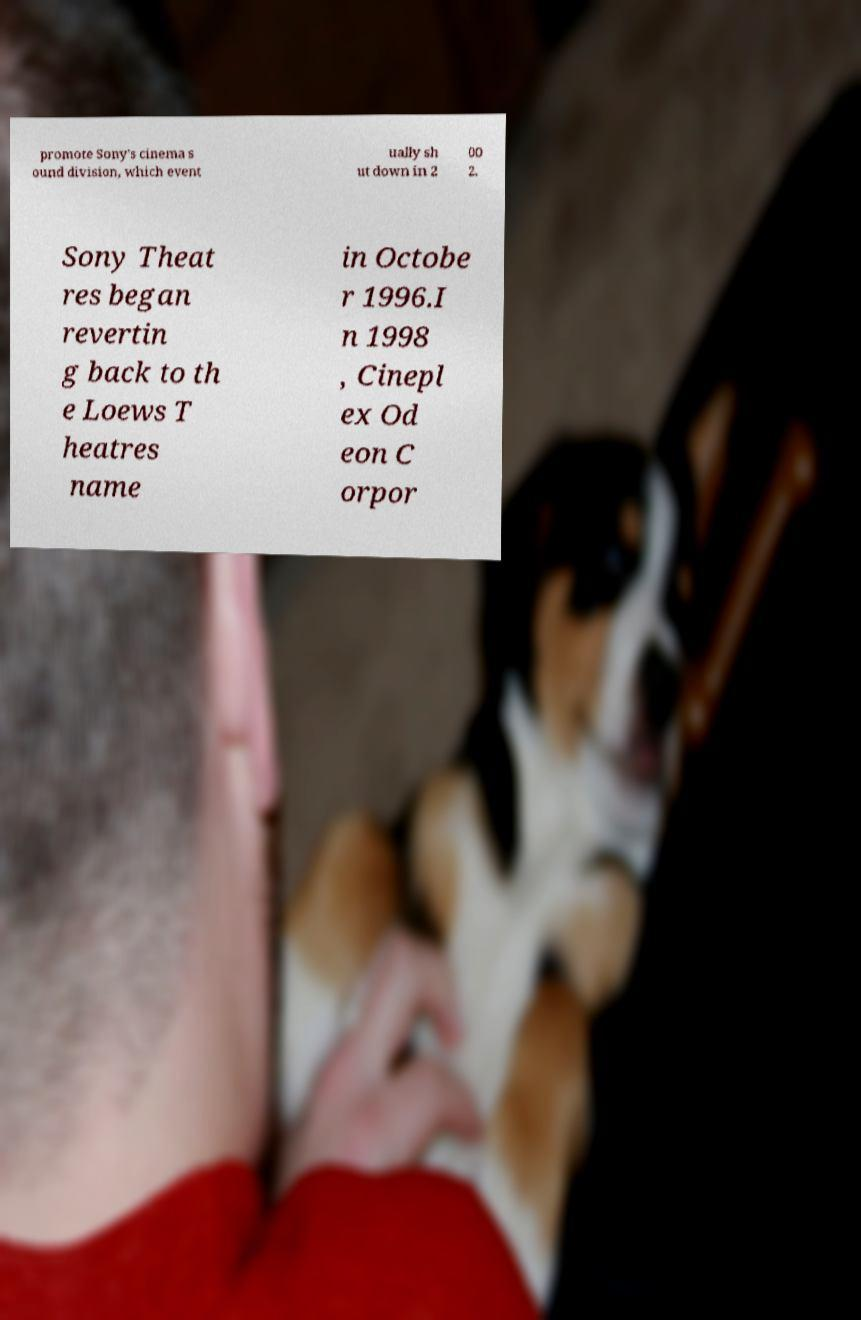Could you assist in decoding the text presented in this image and type it out clearly? promote Sony's cinema s ound division, which event ually sh ut down in 2 00 2. Sony Theat res began revertin g back to th e Loews T heatres name in Octobe r 1996.I n 1998 , Cinepl ex Od eon C orpor 